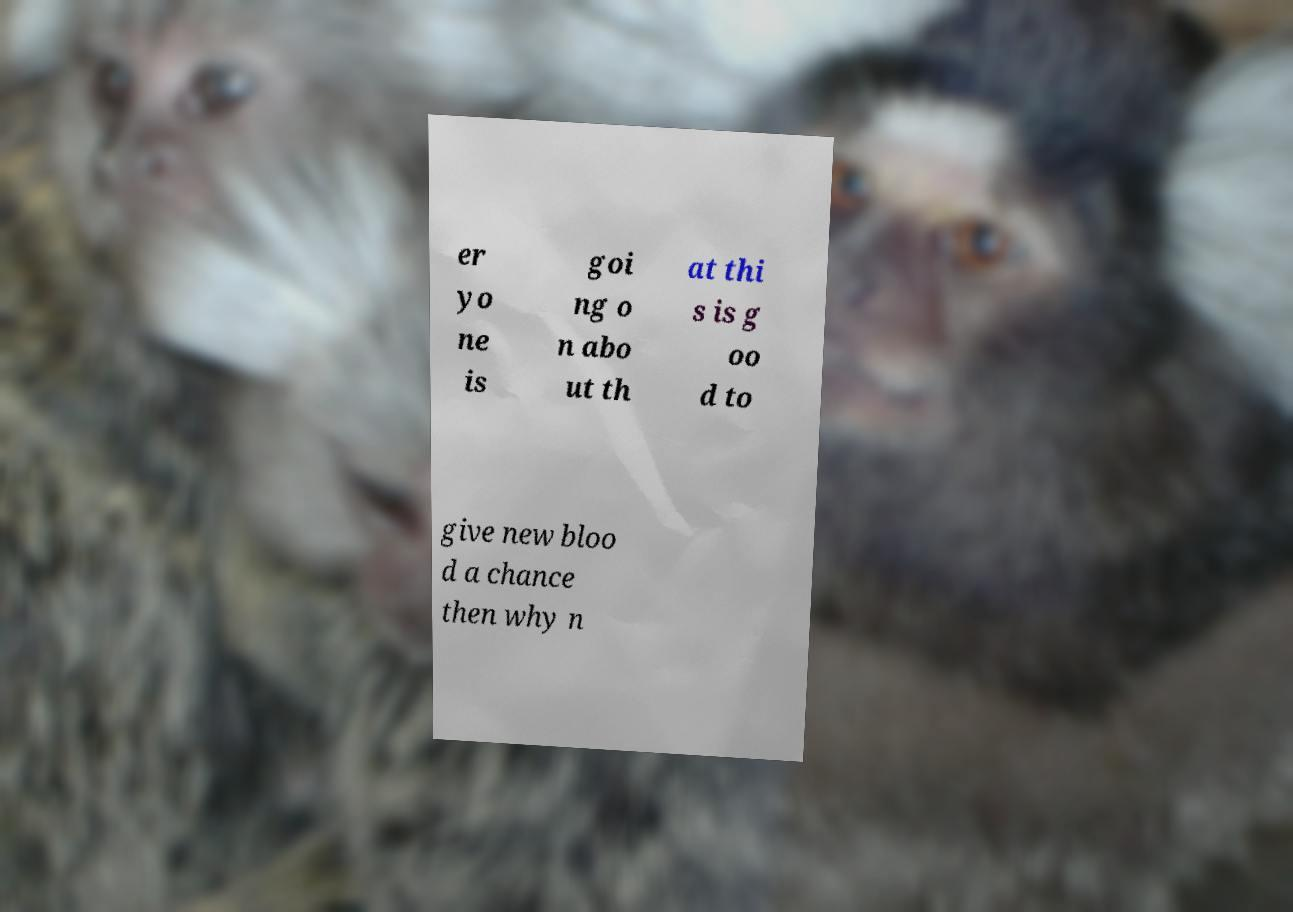Please read and relay the text visible in this image. What does it say? er yo ne is goi ng o n abo ut th at thi s is g oo d to give new bloo d a chance then why n 